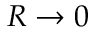Convert formula to latex. <formula><loc_0><loc_0><loc_500><loc_500>R \to 0</formula> 